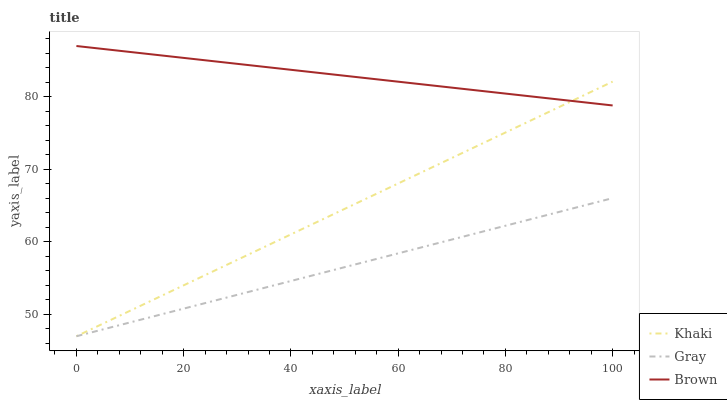Does Khaki have the minimum area under the curve?
Answer yes or no. No. Does Khaki have the maximum area under the curve?
Answer yes or no. No. Is Brown the smoothest?
Answer yes or no. No. Is Brown the roughest?
Answer yes or no. No. Does Brown have the lowest value?
Answer yes or no. No. Does Khaki have the highest value?
Answer yes or no. No. Is Gray less than Brown?
Answer yes or no. Yes. Is Brown greater than Gray?
Answer yes or no. Yes. Does Gray intersect Brown?
Answer yes or no. No. 